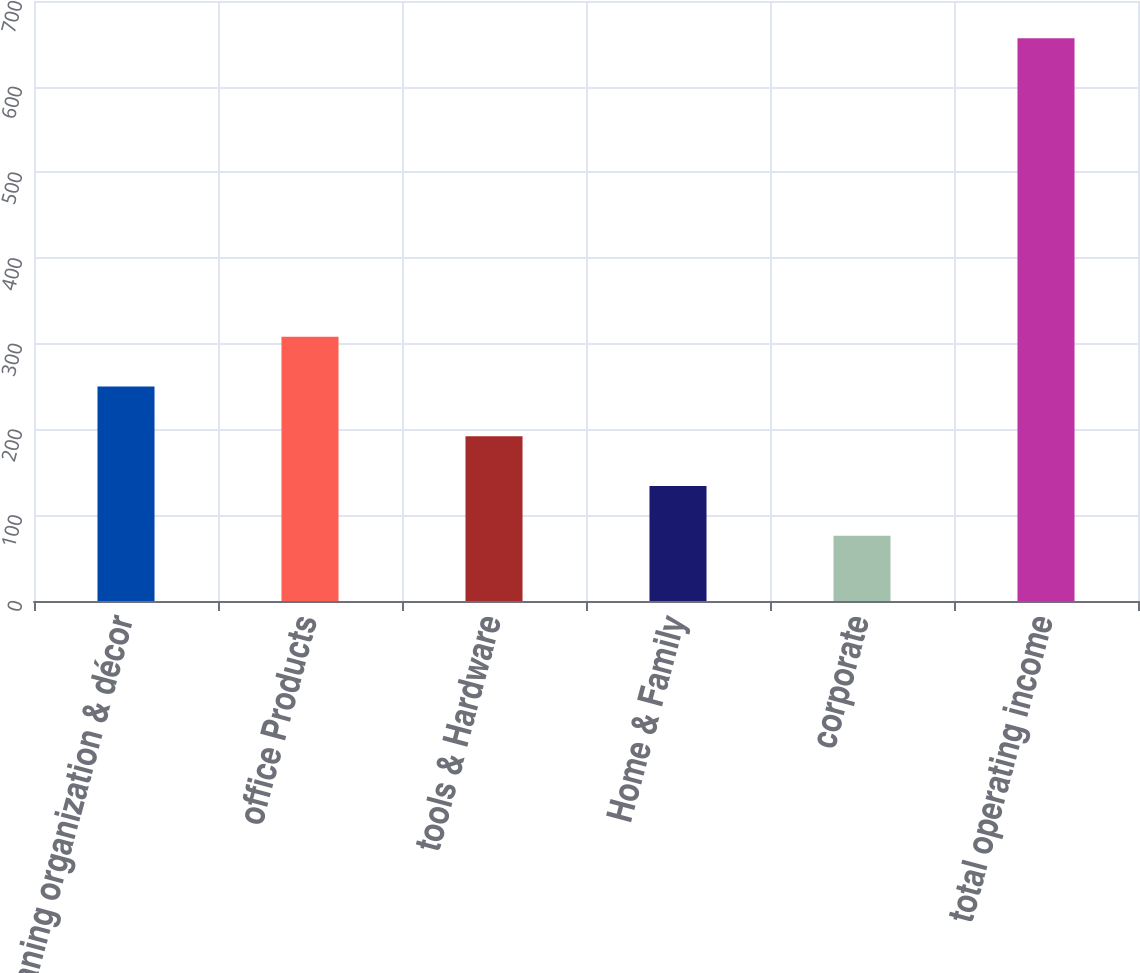Convert chart to OTSL. <chart><loc_0><loc_0><loc_500><loc_500><bar_chart><fcel>cleaning organization & décor<fcel>office Products<fcel>tools & Hardware<fcel>Home & Family<fcel>corporate<fcel>total operating income<nl><fcel>250.18<fcel>308.24<fcel>192.12<fcel>134.06<fcel>76<fcel>656.6<nl></chart> 